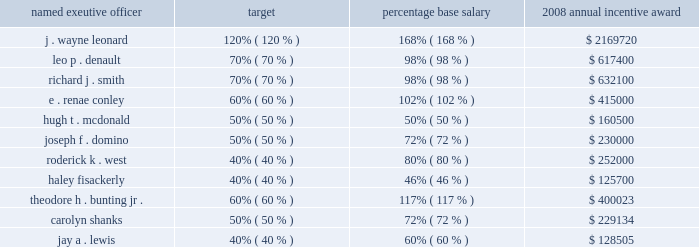After reviewing earnings per share and operating cash flow results against the performance objectives in the above table , the personnel committee set the entergy achievement multiplier at 140% ( 140 % ) of target .
Under the terms of the executive incentive plan , the entergy achievement multiplier is automatically increased by 25 percent for the members of the office of the chief executive ( including mr .
Denault and mr .
Smith , but not the other named executive officers ) , subject to the personnel committee's discretion to adjust the automatic multiplier downward or eliminate it altogether .
In accordance with section 162 ( m ) of the internal revenue code , the multiplier which entergy refers to as the management effectiveness factor is intended to provide the committee , through the exercise of negative discretion , a mechanism to take into consideration the specific achievement factors relating to the overall performance of entergy corporation .
In january 2009 , the committee exercised its negative discretion to eliminate the management effectiveness factor , reflecting the personnel committee's determination that the entergy achievement multiplier , in and of itself without the management effectiveness factor , was consistent with the performance levels achieved by management .
The annual incentive award for the named executive officers ( other than mr .
Leonard , mr .
Denault and mr .
Smith ) is awarded from an incentive pool approved by the committee .
From this pool , each named executive officer's supervisor determines the annual incentive payment based on the entergy achievement multiplier .
The supervisor has the discretion to increase or decrease the multiple used to determine an incentive award based on individual and business unit performance .
The incentive awards are subject to the ultimate approval of entergy's chief executive officer .
The table shows the executive and management incentive plans payments as a percentage of base salary for 2008 : named exeutive officer target percentage base salary 2008 annual incentive award .
While ms .
Shanks and mr .
Lewis are no longer ceo-entergy mississippi and principal financial officer for the subsidiaries , respectively , ms .
Shanks continues to participate in the executive incentive plan , and mr .
Lewis continues to participate in the management incentive plan as they remain employees of entergy since the contemplated enexus separation has not occurred and enexus remains a subsidiary of entergy .
Nuclear retention plan some of entergy's executives , but not any of the named executive officers , participate in a special retention plan for officers and other leaders with special expertise in the nuclear industry .
The committee authorized the plan to attract and retain management talent in the nuclear power field , a field which requires unique technical and other expertise that is in great demand in the utility industry .
The plan provides for bonuses to be paid over a three-year employment period .
Subject to continued employment with a participating company , a participating employee is eligible to receive a special cash bonus consisting of three payments , each consisting of an amount from 15% ( 15 % ) to 30% ( 30 % ) of such participant's base salary. .
What is the difference of annual incentive award between the highest and the lowest award? 
Computations: (2169720 - 125700)
Answer: 2044020.0. 